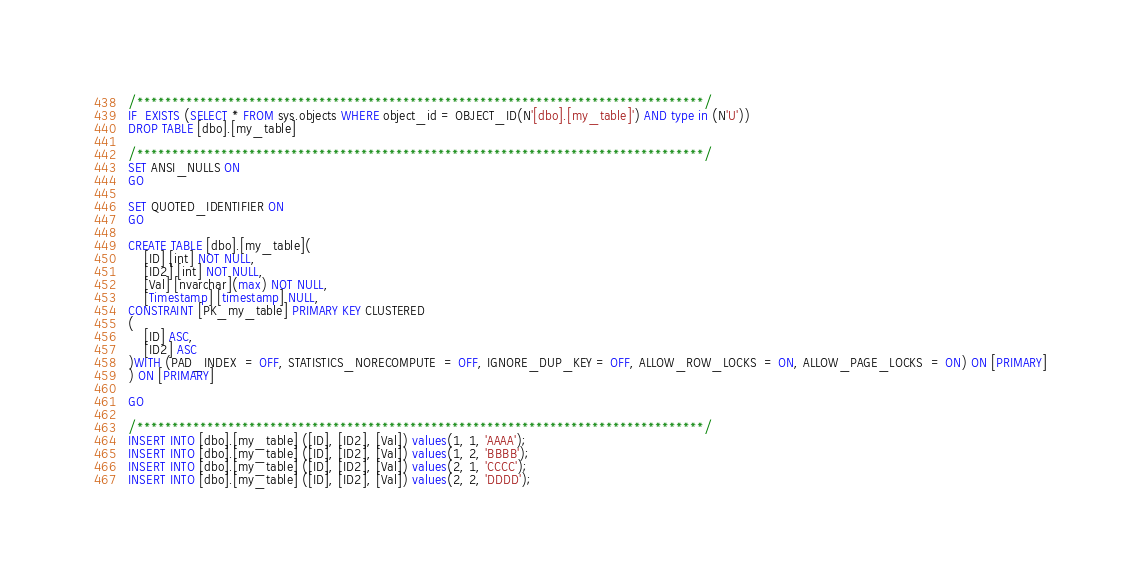<code> <loc_0><loc_0><loc_500><loc_500><_SQL_>/*********************************************************************************/
IF  EXISTS (SELECT * FROM sys.objects WHERE object_id = OBJECT_ID(N'[dbo].[my_table]') AND type in (N'U'))
DROP TABLE [dbo].[my_table]

/*********************************************************************************/
SET ANSI_NULLS ON
GO

SET QUOTED_IDENTIFIER ON
GO

CREATE TABLE [dbo].[my_table](
	[ID] [int] NOT NULL,
	[ID2] [int] NOT NULL,
	[Val] [nvarchar](max) NOT NULL,
	[Timestamp] [timestamp] NULL,
CONSTRAINT [PK_my_table] PRIMARY KEY CLUSTERED 
(
	[ID] ASC,
	[ID2] ASC
)WITH (PAD_INDEX  = OFF, STATISTICS_NORECOMPUTE  = OFF, IGNORE_DUP_KEY = OFF, ALLOW_ROW_LOCKS  = ON, ALLOW_PAGE_LOCKS  = ON) ON [PRIMARY]
) ON [PRIMARY]

GO

/*********************************************************************************/
INSERT INTO [dbo].[my_table] ([ID], [ID2], [Val]) values(1, 1, 'AAAA');
INSERT INTO [dbo].[my_table] ([ID], [ID2], [Val]) values(1, 2, 'BBBB');
INSERT INTO [dbo].[my_table] ([ID], [ID2], [Val]) values(2, 1, 'CCCC');
INSERT INTO [dbo].[my_table] ([ID], [ID2], [Val]) values(2, 2, 'DDDD');
</code> 